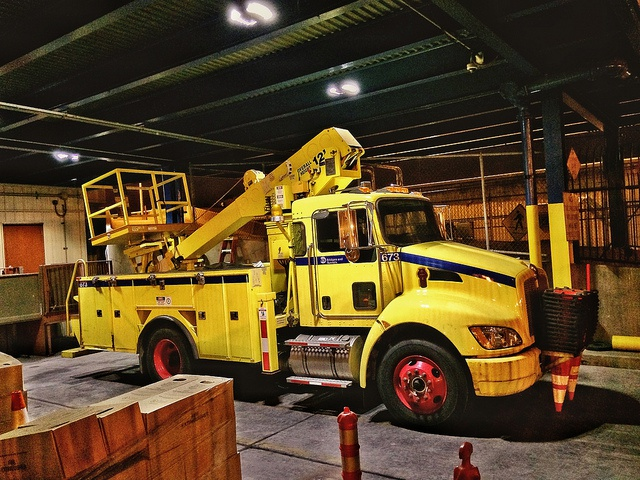Describe the objects in this image and their specific colors. I can see a truck in black, orange, khaki, and maroon tones in this image. 